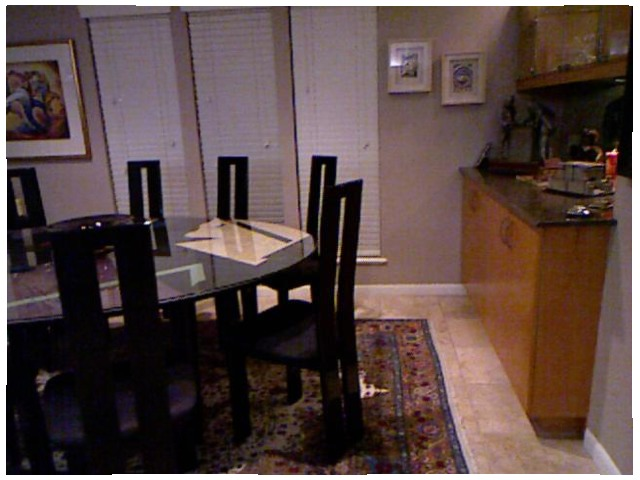<image>
Is there a cup board behind the chair? Yes. From this viewpoint, the cup board is positioned behind the chair, with the chair partially or fully occluding the cup board. Is there a painting behind the chair? Yes. From this viewpoint, the painting is positioned behind the chair, with the chair partially or fully occluding the painting. Where is the table in relation to the chair? Is it behind the chair? No. The table is not behind the chair. From this viewpoint, the table appears to be positioned elsewhere in the scene. Is the chair to the right of the table? Yes. From this viewpoint, the chair is positioned to the right side relative to the table. Is there a dinning table under the chair? No. The dinning table is not positioned under the chair. The vertical relationship between these objects is different. 